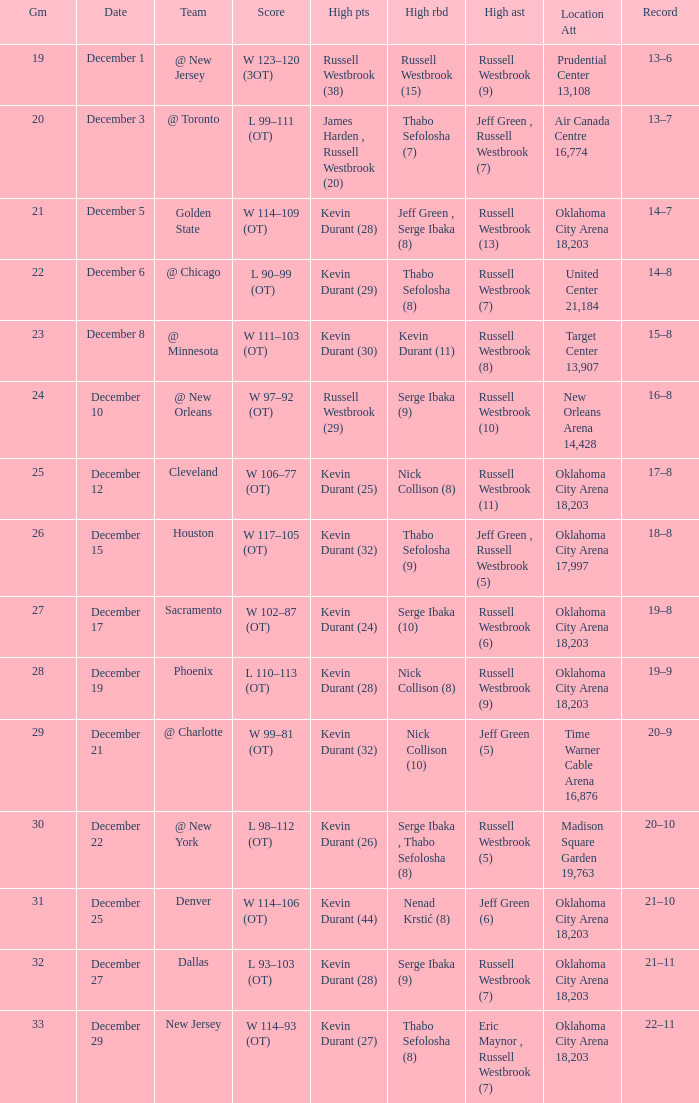What was the record on December 27? 21–11. 